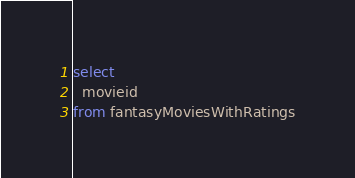Convert code to text. <code><loc_0><loc_0><loc_500><loc_500><_SQL_>select
  movieid
from fantasyMoviesWithRatings</code> 